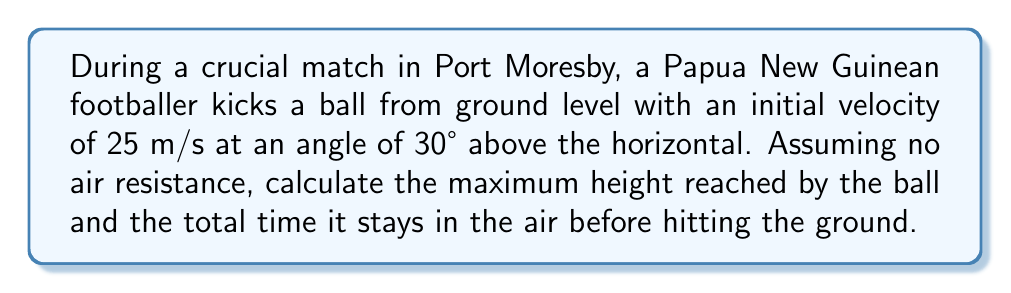Show me your answer to this math problem. Let's approach this problem step-by-step using the equations of projectile motion:

1) First, we need to decompose the initial velocity into its vertical and horizontal components:
   $v_{0x} = v_0 \cos \theta = 25 \cos 30° = 21.65$ m/s
   $v_{0y} = v_0 \sin \theta = 25 \sin 30° = 12.5$ m/s

2) To find the maximum height, we use the equation:
   $h_{max} = \frac{v_{0y}^2}{2g}$
   where $g$ is the acceleration due to gravity (9.8 m/s²)

   $h_{max} = \frac{(12.5)^2}{2(9.8)} = 7.97$ m

3) For the total time in the air, we need to calculate the time to reach the maximum height and double it:
   $t_{up} = \frac{v_{0y}}{g} = \frac{12.5}{9.8} = 1.28$ s

   Total time = $2t_{up} = 2(1.28) = 2.56$ s

Therefore, the ball reaches a maximum height of 7.97 m and stays in the air for 2.56 seconds.
Answer: Maximum height: 7.97 m; Time in air: 2.56 s 